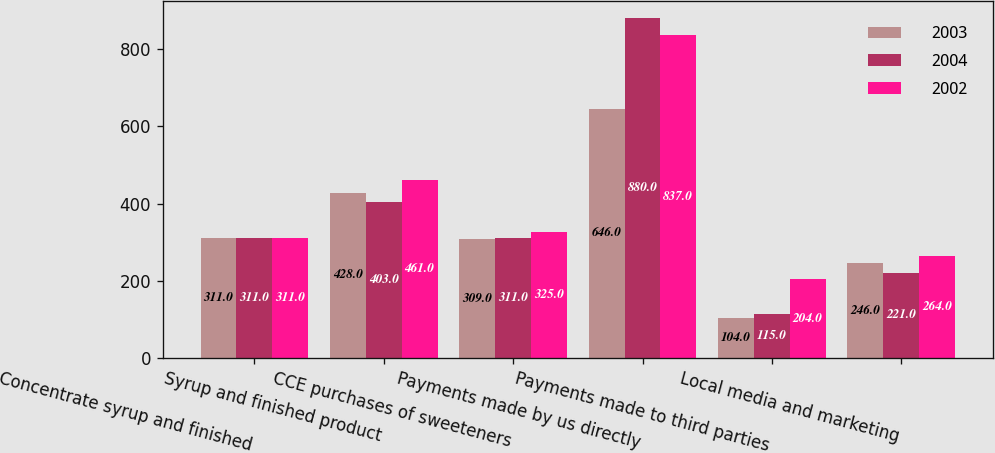Convert chart to OTSL. <chart><loc_0><loc_0><loc_500><loc_500><stacked_bar_chart><ecel><fcel>Concentrate syrup and finished<fcel>Syrup and finished product<fcel>CCE purchases of sweeteners<fcel>Payments made by us directly<fcel>Payments made to third parties<fcel>Local media and marketing<nl><fcel>2003<fcel>311<fcel>428<fcel>309<fcel>646<fcel>104<fcel>246<nl><fcel>2004<fcel>311<fcel>403<fcel>311<fcel>880<fcel>115<fcel>221<nl><fcel>2002<fcel>311<fcel>461<fcel>325<fcel>837<fcel>204<fcel>264<nl></chart> 